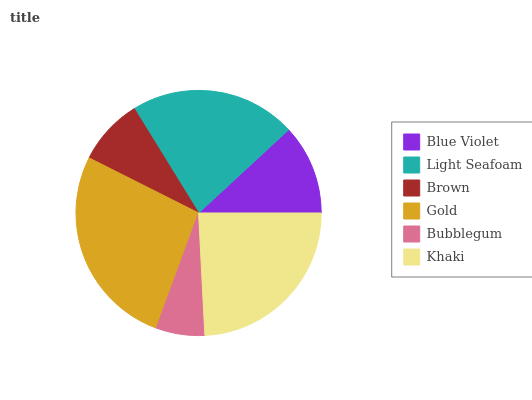Is Bubblegum the minimum?
Answer yes or no. Yes. Is Gold the maximum?
Answer yes or no. Yes. Is Light Seafoam the minimum?
Answer yes or no. No. Is Light Seafoam the maximum?
Answer yes or no. No. Is Light Seafoam greater than Blue Violet?
Answer yes or no. Yes. Is Blue Violet less than Light Seafoam?
Answer yes or no. Yes. Is Blue Violet greater than Light Seafoam?
Answer yes or no. No. Is Light Seafoam less than Blue Violet?
Answer yes or no. No. Is Light Seafoam the high median?
Answer yes or no. Yes. Is Blue Violet the low median?
Answer yes or no. Yes. Is Bubblegum the high median?
Answer yes or no. No. Is Brown the low median?
Answer yes or no. No. 